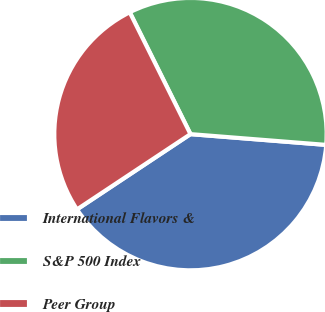Convert chart to OTSL. <chart><loc_0><loc_0><loc_500><loc_500><pie_chart><fcel>International Flavors &<fcel>S&P 500 Index<fcel>Peer Group<nl><fcel>39.42%<fcel>33.62%<fcel>26.96%<nl></chart> 